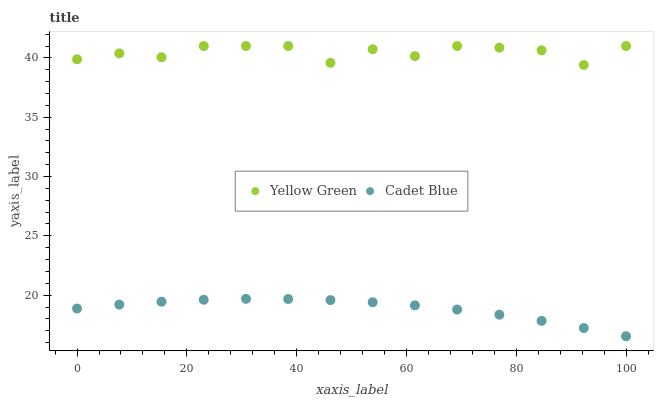Does Cadet Blue have the minimum area under the curve?
Answer yes or no. Yes. Does Yellow Green have the maximum area under the curve?
Answer yes or no. Yes. Does Yellow Green have the minimum area under the curve?
Answer yes or no. No. Is Cadet Blue the smoothest?
Answer yes or no. Yes. Is Yellow Green the roughest?
Answer yes or no. Yes. Is Yellow Green the smoothest?
Answer yes or no. No. Does Cadet Blue have the lowest value?
Answer yes or no. Yes. Does Yellow Green have the lowest value?
Answer yes or no. No. Does Yellow Green have the highest value?
Answer yes or no. Yes. Is Cadet Blue less than Yellow Green?
Answer yes or no. Yes. Is Yellow Green greater than Cadet Blue?
Answer yes or no. Yes. Does Cadet Blue intersect Yellow Green?
Answer yes or no. No. 